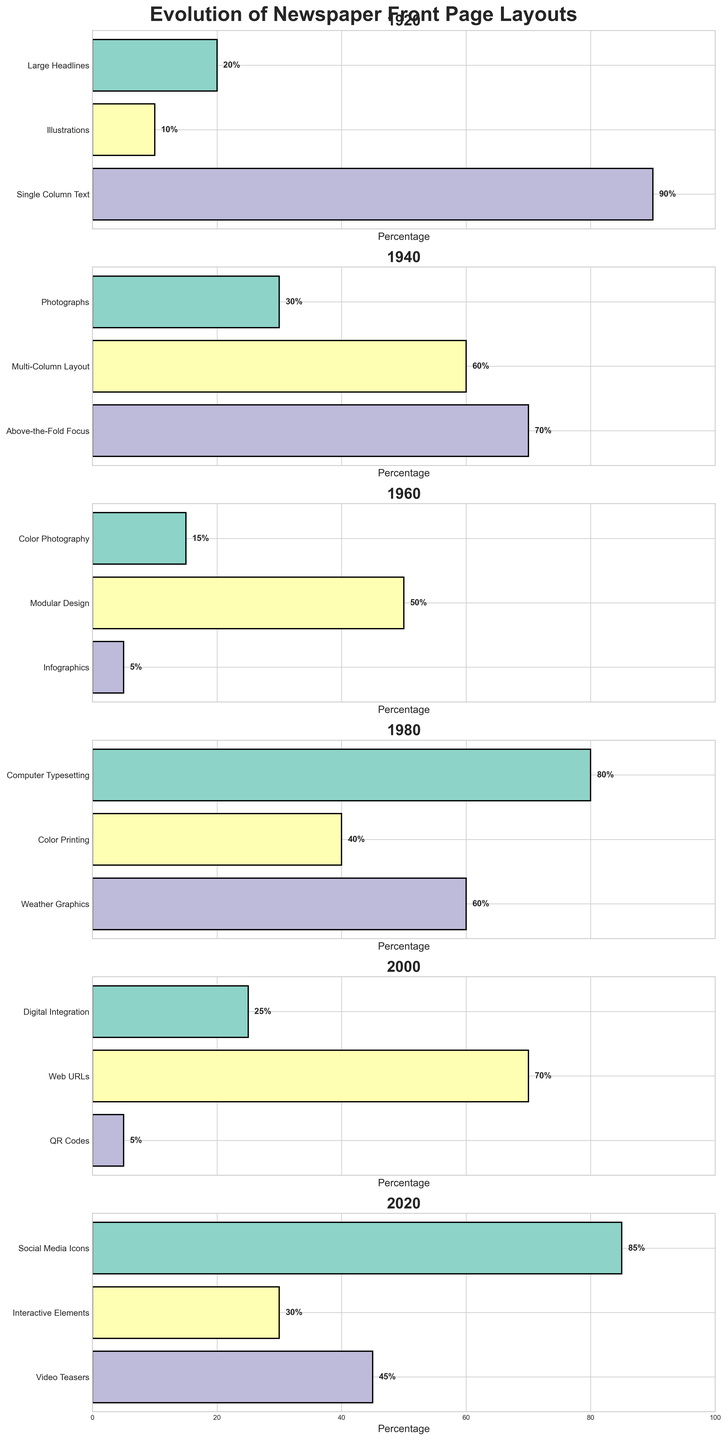What is the title of the figure? The title of the figure is located at the top and provides an overview of the data. It reads 'Evolution of Newspaper Front Page Layouts'.
Answer: Evolution of Newspaper Front Page Layouts What year has the highest percentage for a single feature, and what is the feature? By comparing the bars for each year, we can see that the year 2020 has the highest percentage for a single feature. 'Social Media Icons' stands out as the tallest bar.
Answer: 2020, Social Media Icons Which year introduced 'Photographs' as a feature, and what percentage of the front page did it occupy? We need to look at the subplot for each year. 'Photographs' appear in the subplot for 1940, with a bar indicating 30%.
Answer: 1940, 30% What feature was most common in 1920 based on the percentage, and what was its percentage? Observing the subplot for 1920, 'Single Column Text' has the highest bar and thus the highest percentage, which is 90%.
Answer: Single Column Text, 90% How does the percentage of 'Color Photography' in 1960 compare to 'Color Printing' in 1980? Check the bars for 'Color Photography' in 1960 and 'Color Printing' in 1980. Color Photography in 1960 is 15%, while Color Printing in 1980 is 40%. 'Color Photography' in 1960 is less than 'Color Printing' in 1980.
Answer: Less Between 1960 and 2020, which year had a higher percentage of features dedicated to digital/web integration (includes 'Digital Integration', 'Web URLs', 'QR Codes', 'Social Media Icons', 'Interactive Elements', and 'Video Teasers')? Sum up the percentages for relevant features in 1960 (none exist) and in 2020 ('Social Media Icons' 85%, 'Interactive Elements' 30%, 'Video Teasers' 45%). Only 2020 includes digital/web features and has a total of 85 + 30 + 45 = 160%.
Answer: 2020 In which year did 'Modular Design' become prominent, and what was its percentage? Look through the subplots and identify the bar for 'Modular Design'. It appears in 1960 with a significant percentage of 50%.
Answer: 1960, 50% What is the percentage difference between 'Computer Typesetting' in 1980 and 'Digital Integration' in 2000? Locate the bars for 'Computer Typesetting' in 1980 and 'Digital Integration' in 2000. The difference is calculated as 80% (1980) - 25% (2000) = 55%.
Answer: 55% 